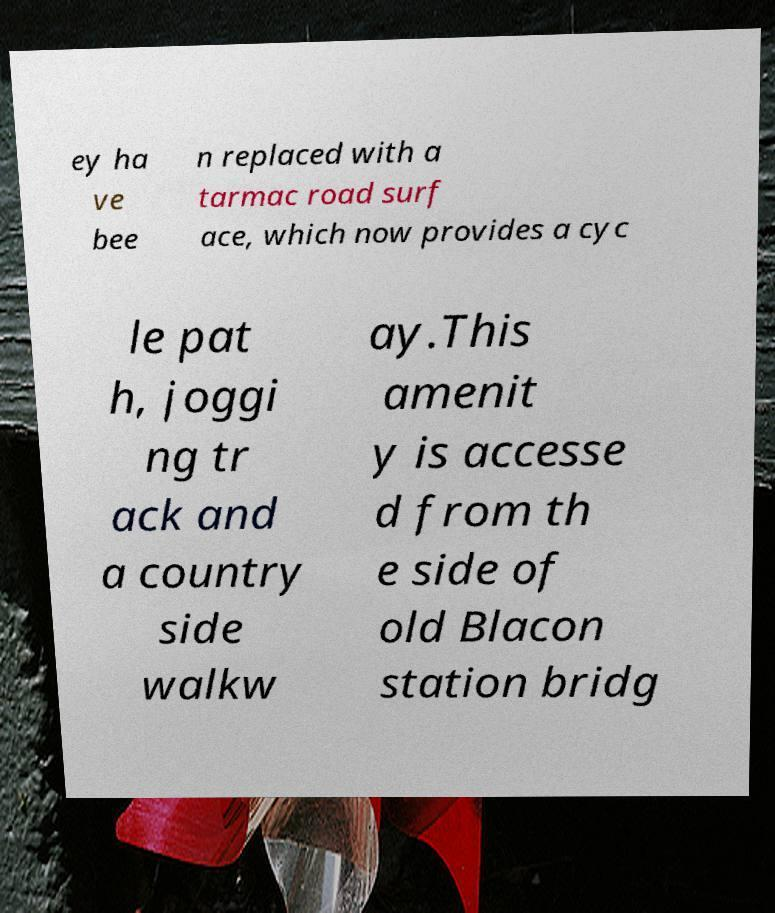Can you read and provide the text displayed in the image?This photo seems to have some interesting text. Can you extract and type it out for me? ey ha ve bee n replaced with a tarmac road surf ace, which now provides a cyc le pat h, joggi ng tr ack and a country side walkw ay.This amenit y is accesse d from th e side of old Blacon station bridg 